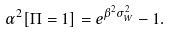Convert formula to latex. <formula><loc_0><loc_0><loc_500><loc_500>\alpha ^ { 2 } [ \Pi = 1 ] = e ^ { \beta ^ { 2 } \sigma _ { W } ^ { 2 } } - 1 .</formula> 